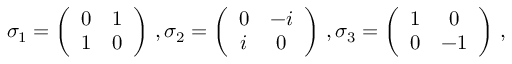<formula> <loc_0><loc_0><loc_500><loc_500>\sigma _ { 1 } = \left ( \begin{array} { c c } { 0 } & { 1 } \\ { 1 } & { 0 } \end{array} \right ) \, , \sigma _ { 2 } = \left ( \begin{array} { c c } { 0 } & { - i } \\ { i } & { 0 } \end{array} \right ) \, , \sigma _ { 3 } = \left ( \begin{array} { c c } { 1 } & { 0 } \\ { 0 } & { - 1 } \end{array} \right ) \, ,</formula> 